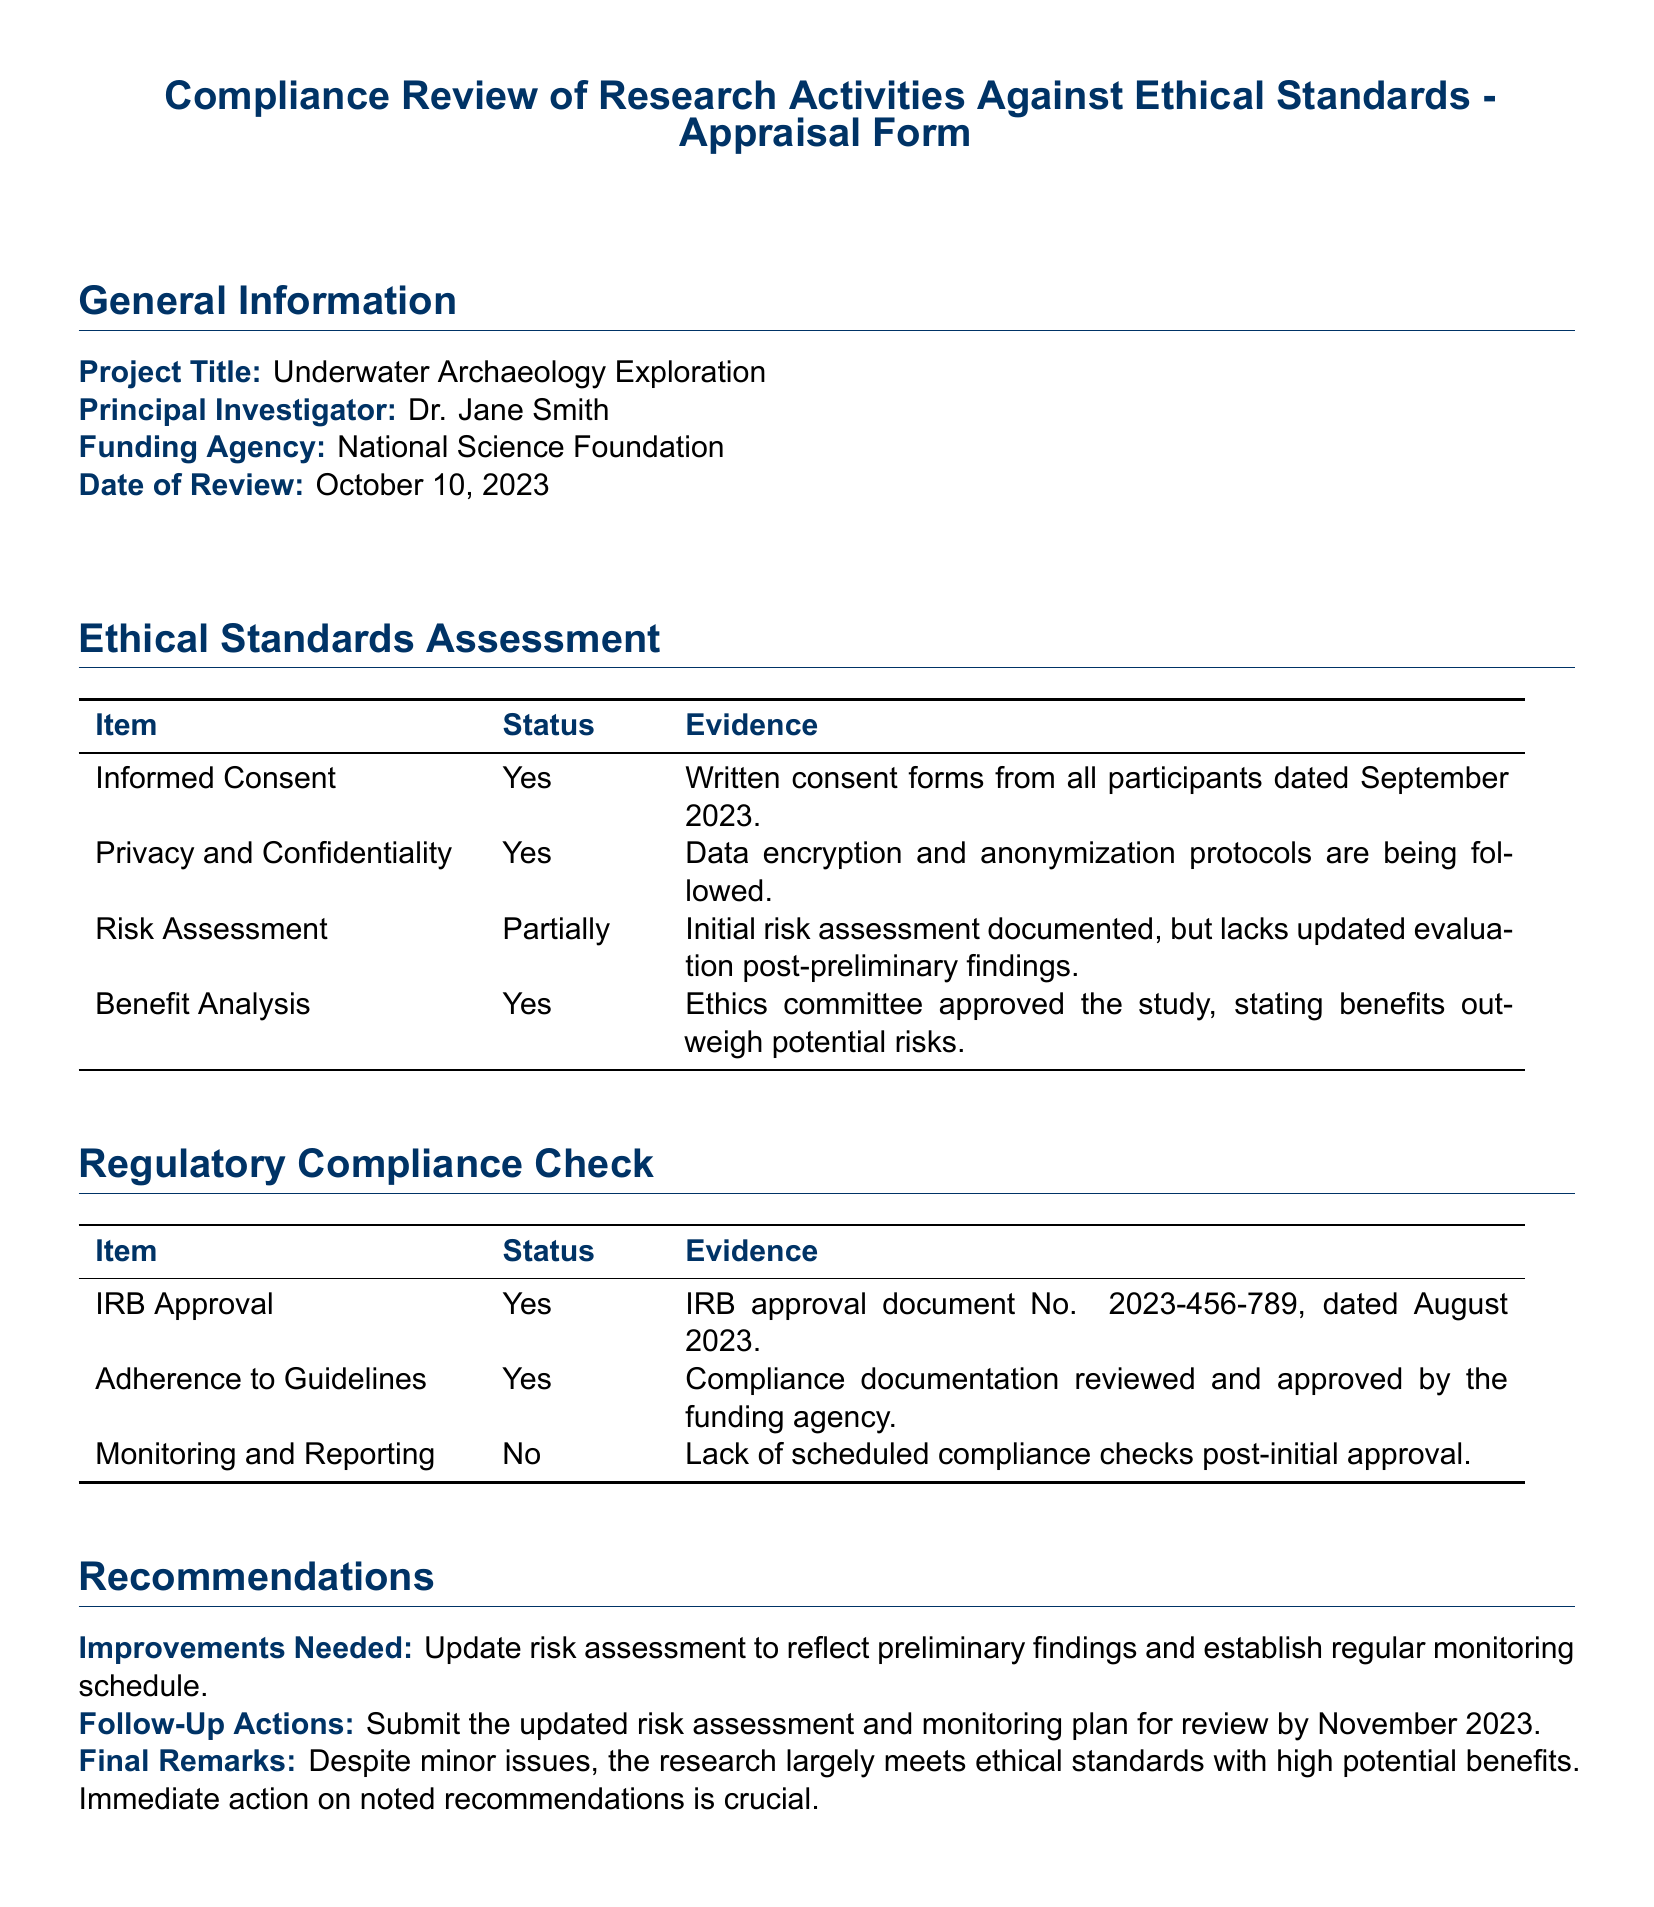What is the project title? The project title is found in the general information section of the document.
Answer: Underwater Archaeology Exploration Who is the principal investigator? The principal investigator's name is specified in the general information section.
Answer: Dr. Jane Smith What is the date of review? The date of review is listed under the general information section.
Answer: October 10, 2023 Is there an IRB approval? The item of IRB approval is checked under the regulatory compliance check section of the document.
Answer: Yes What is the status of the risk assessment? The status of the risk assessment can be found in the ethical standards assessment section.
Answer: Partially What improvements are needed according to the recommendations? The document specifies the needed improvements in the recommendations section.
Answer: Update risk assessment to reflect preliminary findings and establish regular monitoring schedule What is the follow-up action suggested? The follow-up actions are detailed in the recommendations section of the document.
Answer: Submit the updated risk assessment and monitoring plan for review by November 2023 How many items are documented in the ethical standards assessment? The number of items can be counted in the compliance check for ethical standards.
Answer: Four What is indicated about monitoring and reporting? The status related to monitoring and reporting is listed in the regulatory compliance check section.
Answer: No 